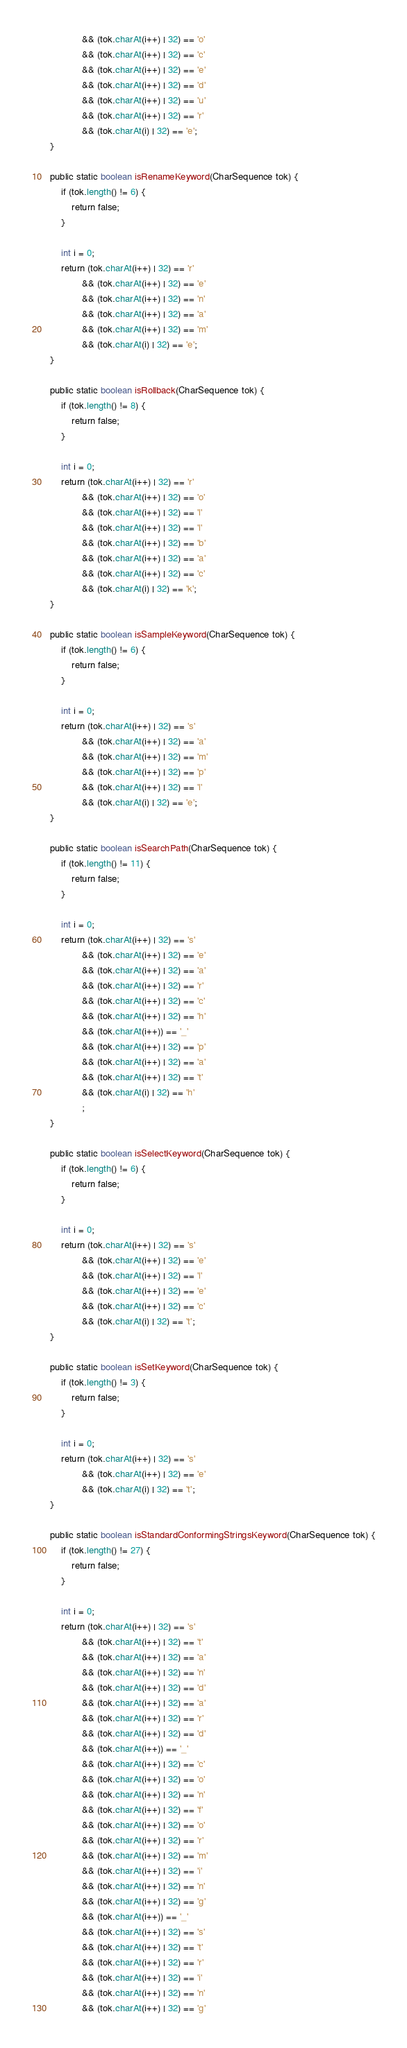Convert code to text. <code><loc_0><loc_0><loc_500><loc_500><_Java_>                && (tok.charAt(i++) | 32) == 'o'
                && (tok.charAt(i++) | 32) == 'c'
                && (tok.charAt(i++) | 32) == 'e'
                && (tok.charAt(i++) | 32) == 'd'
                && (tok.charAt(i++) | 32) == 'u'
                && (tok.charAt(i++) | 32) == 'r'
                && (tok.charAt(i) | 32) == 'e';
    }

    public static boolean isRenameKeyword(CharSequence tok) {
        if (tok.length() != 6) {
            return false;
        }

        int i = 0;
        return (tok.charAt(i++) | 32) == 'r'
                && (tok.charAt(i++) | 32) == 'e'
                && (tok.charAt(i++) | 32) == 'n'
                && (tok.charAt(i++) | 32) == 'a'
                && (tok.charAt(i++) | 32) == 'm'
                && (tok.charAt(i) | 32) == 'e';
    }

    public static boolean isRollback(CharSequence tok) {
        if (tok.length() != 8) {
            return false;
        }

        int i = 0;
        return (tok.charAt(i++) | 32) == 'r'
                && (tok.charAt(i++) | 32) == 'o'
                && (tok.charAt(i++) | 32) == 'l'
                && (tok.charAt(i++) | 32) == 'l'
                && (tok.charAt(i++) | 32) == 'b'
                && (tok.charAt(i++) | 32) == 'a'
                && (tok.charAt(i++) | 32) == 'c'
                && (tok.charAt(i) | 32) == 'k';
    }

    public static boolean isSampleKeyword(CharSequence tok) {
        if (tok.length() != 6) {
            return false;
        }

        int i = 0;
        return (tok.charAt(i++) | 32) == 's'
                && (tok.charAt(i++) | 32) == 'a'
                && (tok.charAt(i++) | 32) == 'm'
                && (tok.charAt(i++) | 32) == 'p'
                && (tok.charAt(i++) | 32) == 'l'
                && (tok.charAt(i) | 32) == 'e';
    }

    public static boolean isSearchPath(CharSequence tok) {
        if (tok.length() != 11) {
            return false;
        }

        int i = 0;
        return (tok.charAt(i++) | 32) == 's'
                && (tok.charAt(i++) | 32) == 'e'
                && (tok.charAt(i++) | 32) == 'a'
                && (tok.charAt(i++) | 32) == 'r'
                && (tok.charAt(i++) | 32) == 'c'
                && (tok.charAt(i++) | 32) == 'h'
                && (tok.charAt(i++)) == '_'
                && (tok.charAt(i++) | 32) == 'p'
                && (tok.charAt(i++) | 32) == 'a'
                && (tok.charAt(i++) | 32) == 't'
                && (tok.charAt(i) | 32) == 'h'
                ;
    }

    public static boolean isSelectKeyword(CharSequence tok) {
        if (tok.length() != 6) {
            return false;
        }

        int i = 0;
        return (tok.charAt(i++) | 32) == 's'
                && (tok.charAt(i++) | 32) == 'e'
                && (tok.charAt(i++) | 32) == 'l'
                && (tok.charAt(i++) | 32) == 'e'
                && (tok.charAt(i++) | 32) == 'c'
                && (tok.charAt(i) | 32) == 't';
    }

    public static boolean isSetKeyword(CharSequence tok) {
        if (tok.length() != 3) {
            return false;
        }

        int i = 0;
        return (tok.charAt(i++) | 32) == 's'
                && (tok.charAt(i++) | 32) == 'e'
                && (tok.charAt(i) | 32) == 't';
    }

    public static boolean isStandardConformingStringsKeyword(CharSequence tok) {
        if (tok.length() != 27) {
            return false;
        }

        int i = 0;
        return (tok.charAt(i++) | 32) == 's'
                && (tok.charAt(i++) | 32) == 't'
                && (tok.charAt(i++) | 32) == 'a'
                && (tok.charAt(i++) | 32) == 'n'
                && (tok.charAt(i++) | 32) == 'd'
                && (tok.charAt(i++) | 32) == 'a'
                && (tok.charAt(i++) | 32) == 'r'
                && (tok.charAt(i++) | 32) == 'd'
                && (tok.charAt(i++)) == '_'
                && (tok.charAt(i++) | 32) == 'c'
                && (tok.charAt(i++) | 32) == 'o'
                && (tok.charAt(i++) | 32) == 'n'
                && (tok.charAt(i++) | 32) == 'f'
                && (tok.charAt(i++) | 32) == 'o'
                && (tok.charAt(i++) | 32) == 'r'
                && (tok.charAt(i++) | 32) == 'm'
                && (tok.charAt(i++) | 32) == 'i'
                && (tok.charAt(i++) | 32) == 'n'
                && (tok.charAt(i++) | 32) == 'g'
                && (tok.charAt(i++)) == '_'
                && (tok.charAt(i++) | 32) == 's'
                && (tok.charAt(i++) | 32) == 't'
                && (tok.charAt(i++) | 32) == 'r'
                && (tok.charAt(i++) | 32) == 'i'
                && (tok.charAt(i++) | 32) == 'n'
                && (tok.charAt(i++) | 32) == 'g'</code> 